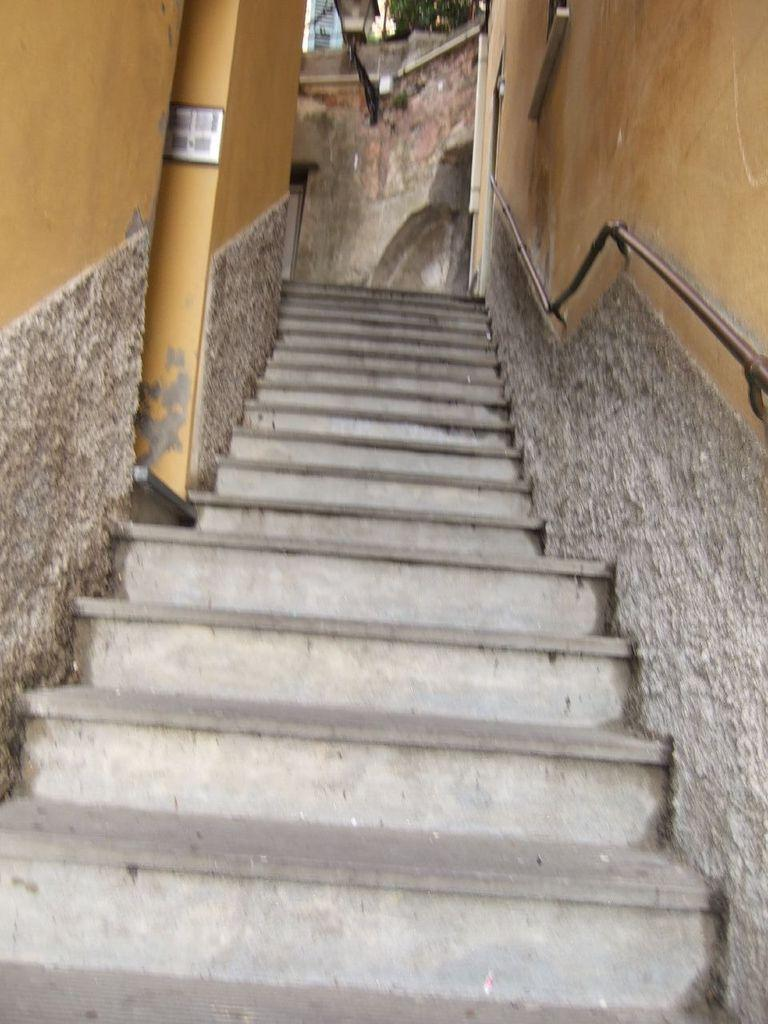What type of architectural feature is present in the image? There are stairs in the image. What else can be seen in the image besides the stairs? There is a wall in the image. What type of base is used to support the stairs in the image? There is no information provided about the base supporting the stairs in the image. What meal is being prepared on the side of the stairs in the image? There is no meal or cooking activity depicted in the image; it only features stairs and a wall. 